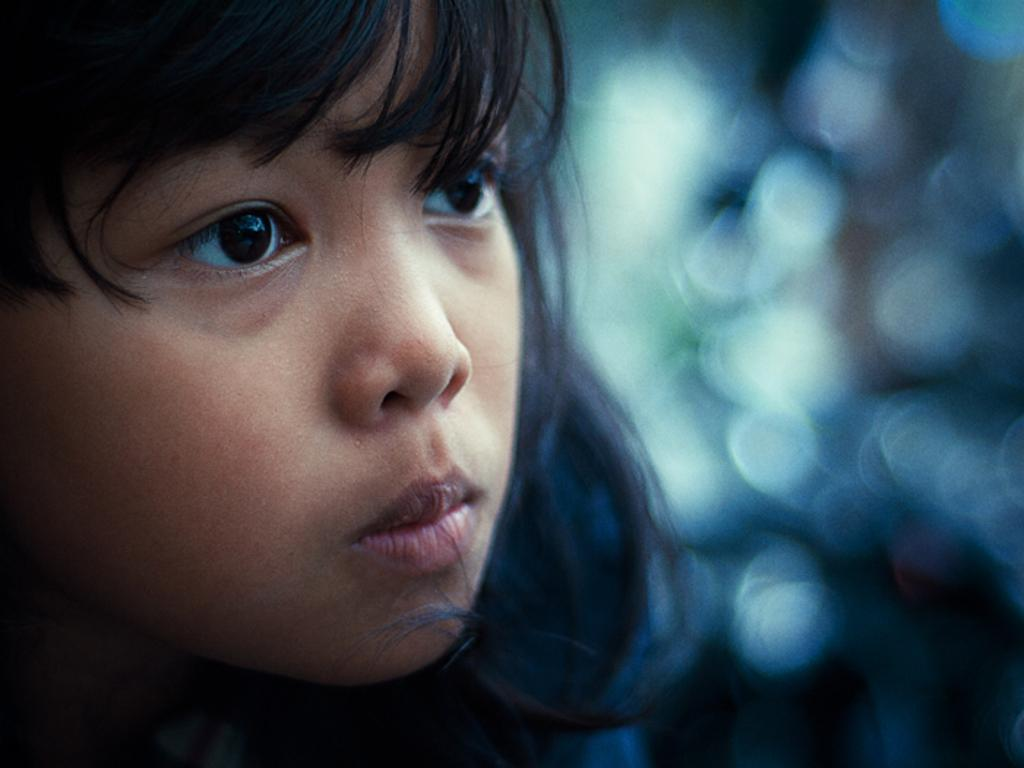What is the main subject of the image? There is a kid in the image. What type of scissors is the kid using to cut the skate in the image? There is no skate or scissors present in the image; it only features a kid. 